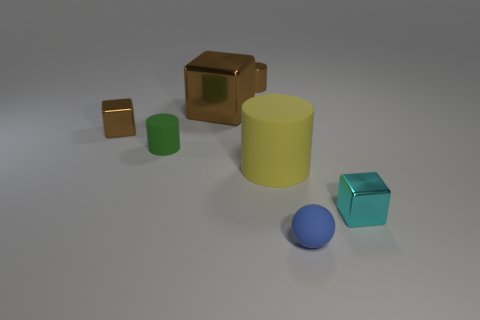Add 3 small balls. How many objects exist? 10 Subtract all cubes. How many objects are left? 4 Add 4 metallic objects. How many metallic objects exist? 8 Subtract 0 red blocks. How many objects are left? 7 Subtract all big matte objects. Subtract all small shiny objects. How many objects are left? 3 Add 1 big shiny objects. How many big shiny objects are left? 2 